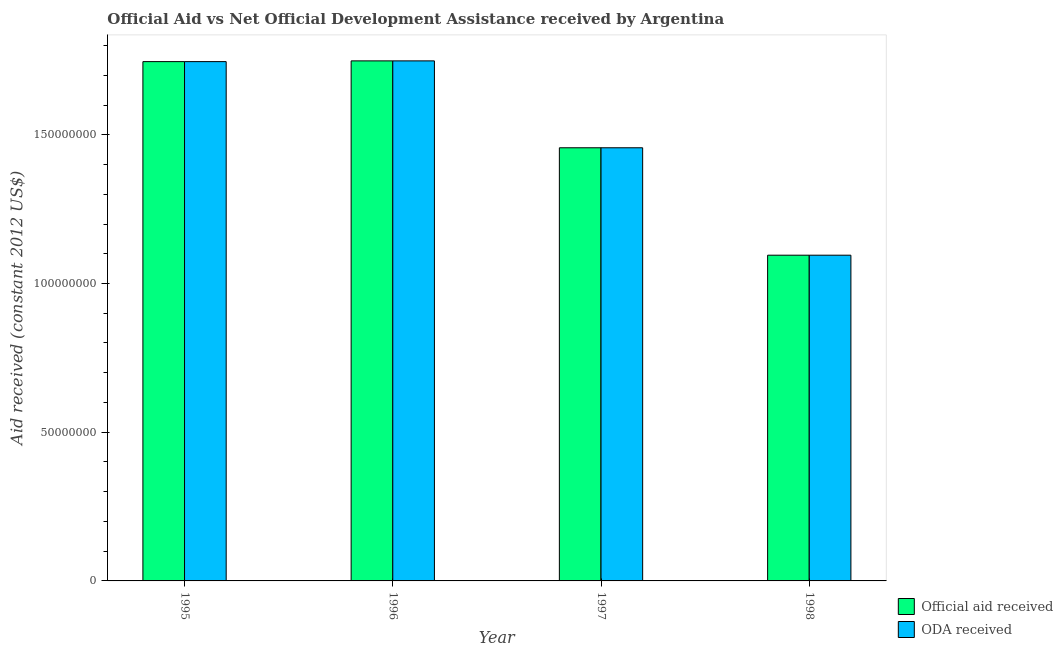How many groups of bars are there?
Offer a very short reply. 4. Are the number of bars on each tick of the X-axis equal?
Provide a succinct answer. Yes. How many bars are there on the 4th tick from the left?
Provide a succinct answer. 2. What is the official aid received in 1997?
Your answer should be compact. 1.46e+08. Across all years, what is the maximum oda received?
Provide a succinct answer. 1.75e+08. Across all years, what is the minimum oda received?
Provide a short and direct response. 1.10e+08. What is the total official aid received in the graph?
Your answer should be very brief. 6.05e+08. What is the difference between the official aid received in 1996 and that in 1998?
Your response must be concise. 6.53e+07. What is the difference between the oda received in 1996 and the official aid received in 1998?
Offer a terse response. 6.53e+07. What is the average oda received per year?
Your response must be concise. 1.51e+08. In how many years, is the oda received greater than 170000000 US$?
Make the answer very short. 2. What is the ratio of the official aid received in 1995 to that in 1997?
Your response must be concise. 1.2. Is the difference between the official aid received in 1995 and 1998 greater than the difference between the oda received in 1995 and 1998?
Your response must be concise. No. What is the difference between the highest and the lowest oda received?
Your answer should be compact. 6.53e+07. Is the sum of the official aid received in 1996 and 1998 greater than the maximum oda received across all years?
Ensure brevity in your answer.  Yes. What does the 2nd bar from the left in 1995 represents?
Keep it short and to the point. ODA received. What does the 2nd bar from the right in 1998 represents?
Offer a terse response. Official aid received. Are all the bars in the graph horizontal?
Your answer should be compact. No. Are the values on the major ticks of Y-axis written in scientific E-notation?
Give a very brief answer. No. Where does the legend appear in the graph?
Ensure brevity in your answer.  Bottom right. How many legend labels are there?
Keep it short and to the point. 2. What is the title of the graph?
Your answer should be very brief. Official Aid vs Net Official Development Assistance received by Argentina . What is the label or title of the Y-axis?
Your answer should be very brief. Aid received (constant 2012 US$). What is the Aid received (constant 2012 US$) in Official aid received in 1995?
Give a very brief answer. 1.75e+08. What is the Aid received (constant 2012 US$) of ODA received in 1995?
Give a very brief answer. 1.75e+08. What is the Aid received (constant 2012 US$) in Official aid received in 1996?
Provide a succinct answer. 1.75e+08. What is the Aid received (constant 2012 US$) in ODA received in 1996?
Your response must be concise. 1.75e+08. What is the Aid received (constant 2012 US$) in Official aid received in 1997?
Your answer should be compact. 1.46e+08. What is the Aid received (constant 2012 US$) in ODA received in 1997?
Your response must be concise. 1.46e+08. What is the Aid received (constant 2012 US$) in Official aid received in 1998?
Give a very brief answer. 1.10e+08. What is the Aid received (constant 2012 US$) of ODA received in 1998?
Offer a terse response. 1.10e+08. Across all years, what is the maximum Aid received (constant 2012 US$) in Official aid received?
Give a very brief answer. 1.75e+08. Across all years, what is the maximum Aid received (constant 2012 US$) in ODA received?
Your answer should be very brief. 1.75e+08. Across all years, what is the minimum Aid received (constant 2012 US$) of Official aid received?
Provide a short and direct response. 1.10e+08. Across all years, what is the minimum Aid received (constant 2012 US$) in ODA received?
Give a very brief answer. 1.10e+08. What is the total Aid received (constant 2012 US$) of Official aid received in the graph?
Ensure brevity in your answer.  6.05e+08. What is the total Aid received (constant 2012 US$) in ODA received in the graph?
Your response must be concise. 6.05e+08. What is the difference between the Aid received (constant 2012 US$) of Official aid received in 1995 and that in 1996?
Your answer should be very brief. -2.50e+05. What is the difference between the Aid received (constant 2012 US$) of ODA received in 1995 and that in 1996?
Provide a short and direct response. -2.50e+05. What is the difference between the Aid received (constant 2012 US$) in Official aid received in 1995 and that in 1997?
Your answer should be compact. 2.90e+07. What is the difference between the Aid received (constant 2012 US$) of ODA received in 1995 and that in 1997?
Your answer should be very brief. 2.90e+07. What is the difference between the Aid received (constant 2012 US$) of Official aid received in 1995 and that in 1998?
Provide a short and direct response. 6.51e+07. What is the difference between the Aid received (constant 2012 US$) in ODA received in 1995 and that in 1998?
Give a very brief answer. 6.51e+07. What is the difference between the Aid received (constant 2012 US$) in Official aid received in 1996 and that in 1997?
Provide a succinct answer. 2.92e+07. What is the difference between the Aid received (constant 2012 US$) in ODA received in 1996 and that in 1997?
Keep it short and to the point. 2.92e+07. What is the difference between the Aid received (constant 2012 US$) in Official aid received in 1996 and that in 1998?
Ensure brevity in your answer.  6.53e+07. What is the difference between the Aid received (constant 2012 US$) of ODA received in 1996 and that in 1998?
Give a very brief answer. 6.53e+07. What is the difference between the Aid received (constant 2012 US$) of Official aid received in 1997 and that in 1998?
Ensure brevity in your answer.  3.61e+07. What is the difference between the Aid received (constant 2012 US$) of ODA received in 1997 and that in 1998?
Provide a succinct answer. 3.61e+07. What is the difference between the Aid received (constant 2012 US$) in Official aid received in 1995 and the Aid received (constant 2012 US$) in ODA received in 1996?
Give a very brief answer. -2.50e+05. What is the difference between the Aid received (constant 2012 US$) in Official aid received in 1995 and the Aid received (constant 2012 US$) in ODA received in 1997?
Your answer should be very brief. 2.90e+07. What is the difference between the Aid received (constant 2012 US$) in Official aid received in 1995 and the Aid received (constant 2012 US$) in ODA received in 1998?
Ensure brevity in your answer.  6.51e+07. What is the difference between the Aid received (constant 2012 US$) in Official aid received in 1996 and the Aid received (constant 2012 US$) in ODA received in 1997?
Keep it short and to the point. 2.92e+07. What is the difference between the Aid received (constant 2012 US$) of Official aid received in 1996 and the Aid received (constant 2012 US$) of ODA received in 1998?
Offer a terse response. 6.53e+07. What is the difference between the Aid received (constant 2012 US$) of Official aid received in 1997 and the Aid received (constant 2012 US$) of ODA received in 1998?
Make the answer very short. 3.61e+07. What is the average Aid received (constant 2012 US$) of Official aid received per year?
Make the answer very short. 1.51e+08. What is the average Aid received (constant 2012 US$) of ODA received per year?
Ensure brevity in your answer.  1.51e+08. In the year 1995, what is the difference between the Aid received (constant 2012 US$) of Official aid received and Aid received (constant 2012 US$) of ODA received?
Offer a very short reply. 0. In the year 1996, what is the difference between the Aid received (constant 2012 US$) in Official aid received and Aid received (constant 2012 US$) in ODA received?
Offer a terse response. 0. In the year 1997, what is the difference between the Aid received (constant 2012 US$) in Official aid received and Aid received (constant 2012 US$) in ODA received?
Offer a terse response. 0. What is the ratio of the Aid received (constant 2012 US$) in Official aid received in 1995 to that in 1997?
Offer a terse response. 1.2. What is the ratio of the Aid received (constant 2012 US$) in ODA received in 1995 to that in 1997?
Provide a succinct answer. 1.2. What is the ratio of the Aid received (constant 2012 US$) in Official aid received in 1995 to that in 1998?
Your answer should be very brief. 1.59. What is the ratio of the Aid received (constant 2012 US$) in ODA received in 1995 to that in 1998?
Offer a very short reply. 1.59. What is the ratio of the Aid received (constant 2012 US$) in Official aid received in 1996 to that in 1997?
Provide a succinct answer. 1.2. What is the ratio of the Aid received (constant 2012 US$) of ODA received in 1996 to that in 1997?
Provide a short and direct response. 1.2. What is the ratio of the Aid received (constant 2012 US$) of Official aid received in 1996 to that in 1998?
Make the answer very short. 1.6. What is the ratio of the Aid received (constant 2012 US$) in ODA received in 1996 to that in 1998?
Provide a short and direct response. 1.6. What is the ratio of the Aid received (constant 2012 US$) in Official aid received in 1997 to that in 1998?
Offer a terse response. 1.33. What is the ratio of the Aid received (constant 2012 US$) of ODA received in 1997 to that in 1998?
Keep it short and to the point. 1.33. What is the difference between the highest and the second highest Aid received (constant 2012 US$) in ODA received?
Your answer should be very brief. 2.50e+05. What is the difference between the highest and the lowest Aid received (constant 2012 US$) of Official aid received?
Your response must be concise. 6.53e+07. What is the difference between the highest and the lowest Aid received (constant 2012 US$) of ODA received?
Offer a very short reply. 6.53e+07. 